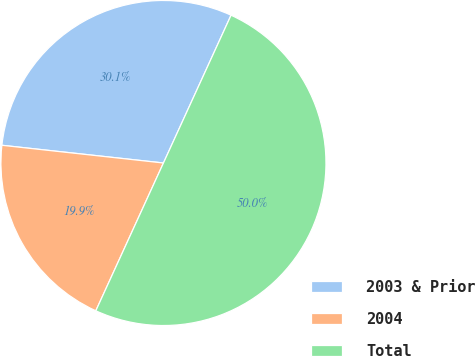Convert chart. <chart><loc_0><loc_0><loc_500><loc_500><pie_chart><fcel>2003 & Prior<fcel>2004<fcel>Total<nl><fcel>30.09%<fcel>19.91%<fcel>50.0%<nl></chart> 